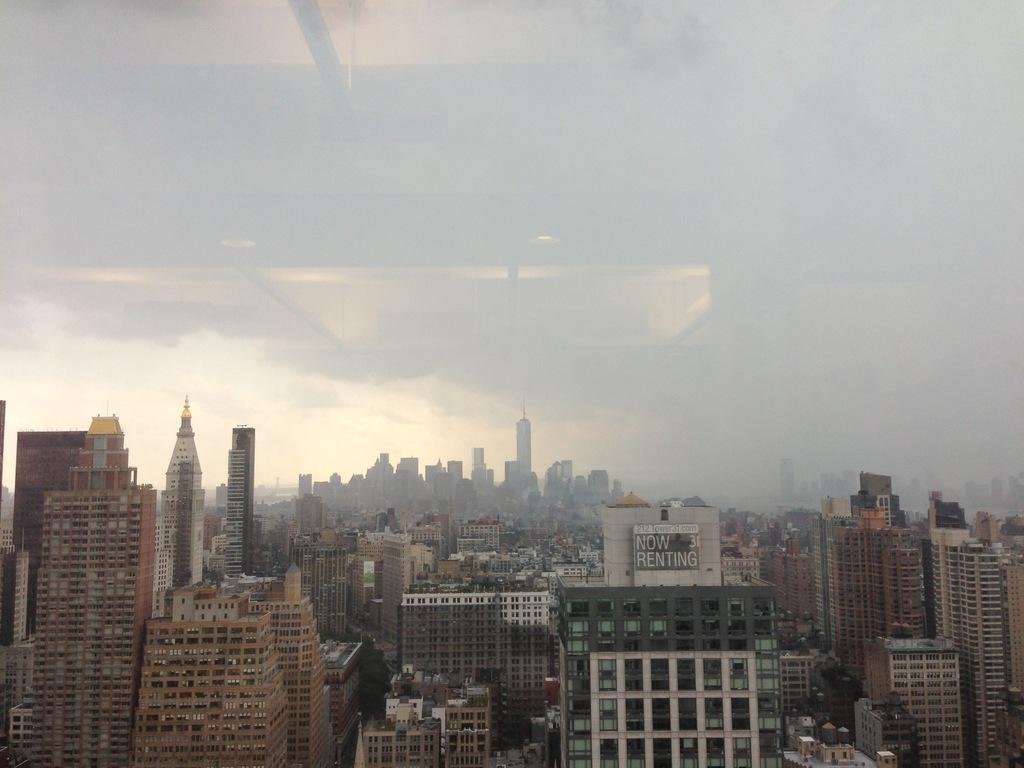What type of structures can be seen in the image? There are buildings in the image. What is written or displayed on the board in the image? There is a board with text in the image. What atmospheric condition is present in the image? Fog is visible in the image. What can be seen reflecting off the glass surface in the image? There is a reflection of lights in the glass. From where was the image likely taken? The image appears to be taken from behind a glass surface. How does the shock affect the spring in the image? There is no shock or spring present in the image; it features buildings, a board with text, fog, and a reflection of lights in the glass. What is the attention span of the person in the image? There is no person present in the image, so it is not possible to determine their attention span. 